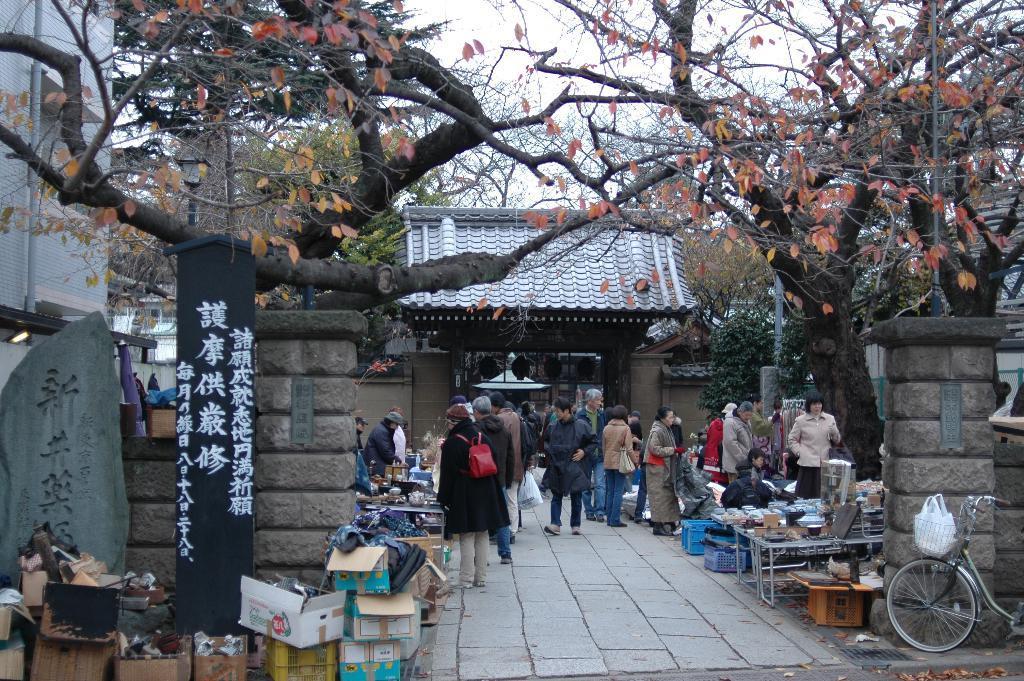In one or two sentences, can you explain what this image depicts? In this image, we can see people standing and wearing coats and some are wearing bags and in the background, there are boxes, boards, stands, containers, trees, buildings, pillars and a bicycle and we can see some other objects. At the bottom, there is a road. 